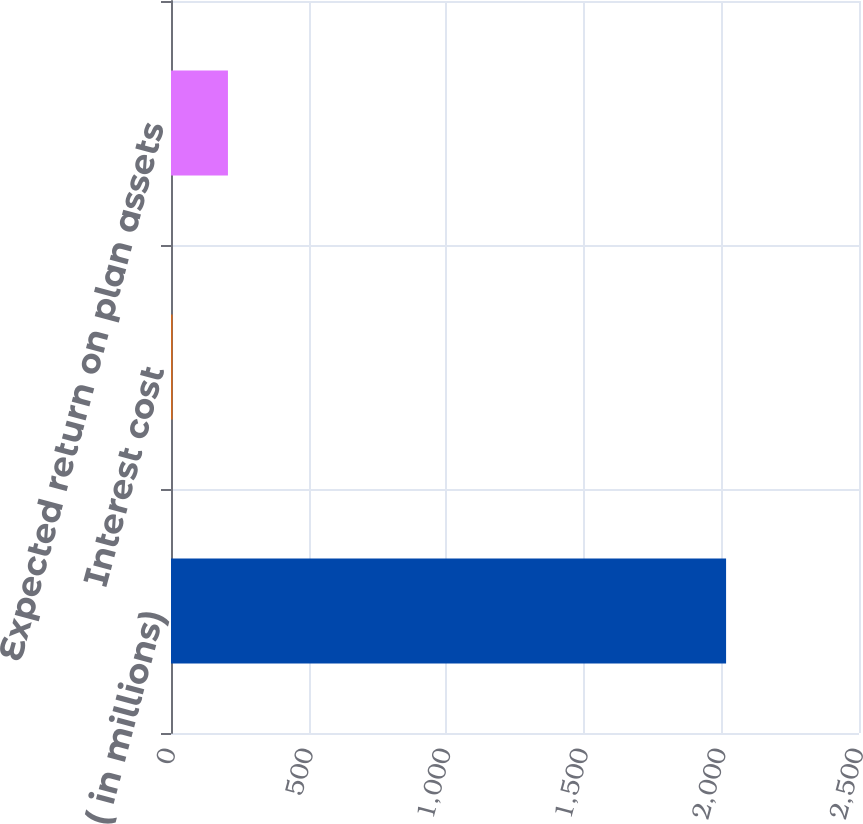Convert chart to OTSL. <chart><loc_0><loc_0><loc_500><loc_500><bar_chart><fcel>( in millions)<fcel>Interest cost<fcel>Expected return on plan assets<nl><fcel>2017<fcel>5.8<fcel>206.92<nl></chart> 